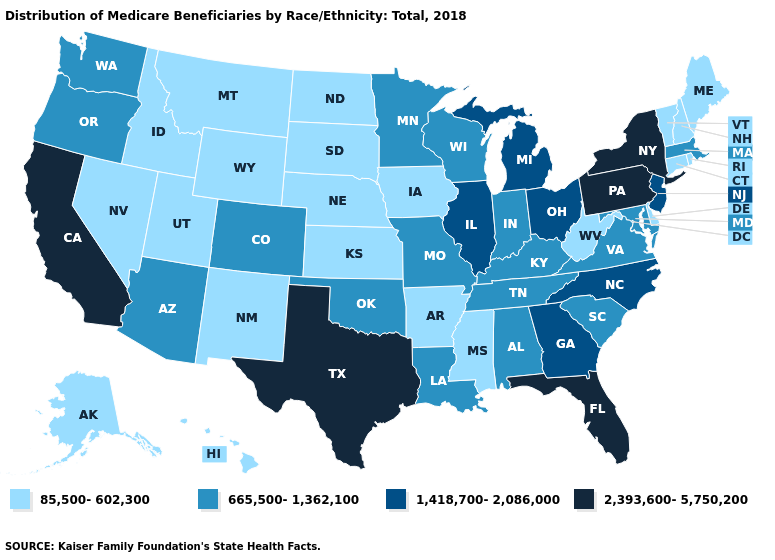Among the states that border New York , which have the lowest value?
Be succinct. Connecticut, Vermont. Does Arkansas have the lowest value in the USA?
Be succinct. Yes. Name the states that have a value in the range 2,393,600-5,750,200?
Short answer required. California, Florida, New York, Pennsylvania, Texas. What is the value of Ohio?
Short answer required. 1,418,700-2,086,000. Name the states that have a value in the range 85,500-602,300?
Be succinct. Alaska, Arkansas, Connecticut, Delaware, Hawaii, Idaho, Iowa, Kansas, Maine, Mississippi, Montana, Nebraska, Nevada, New Hampshire, New Mexico, North Dakota, Rhode Island, South Dakota, Utah, Vermont, West Virginia, Wyoming. Is the legend a continuous bar?
Answer briefly. No. Does Tennessee have the same value as Louisiana?
Keep it brief. Yes. Among the states that border Idaho , which have the highest value?
Quick response, please. Oregon, Washington. Which states have the lowest value in the MidWest?
Short answer required. Iowa, Kansas, Nebraska, North Dakota, South Dakota. Which states have the lowest value in the USA?
Concise answer only. Alaska, Arkansas, Connecticut, Delaware, Hawaii, Idaho, Iowa, Kansas, Maine, Mississippi, Montana, Nebraska, Nevada, New Hampshire, New Mexico, North Dakota, Rhode Island, South Dakota, Utah, Vermont, West Virginia, Wyoming. Which states have the lowest value in the West?
Be succinct. Alaska, Hawaii, Idaho, Montana, Nevada, New Mexico, Utah, Wyoming. Does the map have missing data?
Concise answer only. No. What is the value of Florida?
Be succinct. 2,393,600-5,750,200. Among the states that border Florida , which have the lowest value?
Concise answer only. Alabama. Name the states that have a value in the range 85,500-602,300?
Give a very brief answer. Alaska, Arkansas, Connecticut, Delaware, Hawaii, Idaho, Iowa, Kansas, Maine, Mississippi, Montana, Nebraska, Nevada, New Hampshire, New Mexico, North Dakota, Rhode Island, South Dakota, Utah, Vermont, West Virginia, Wyoming. 